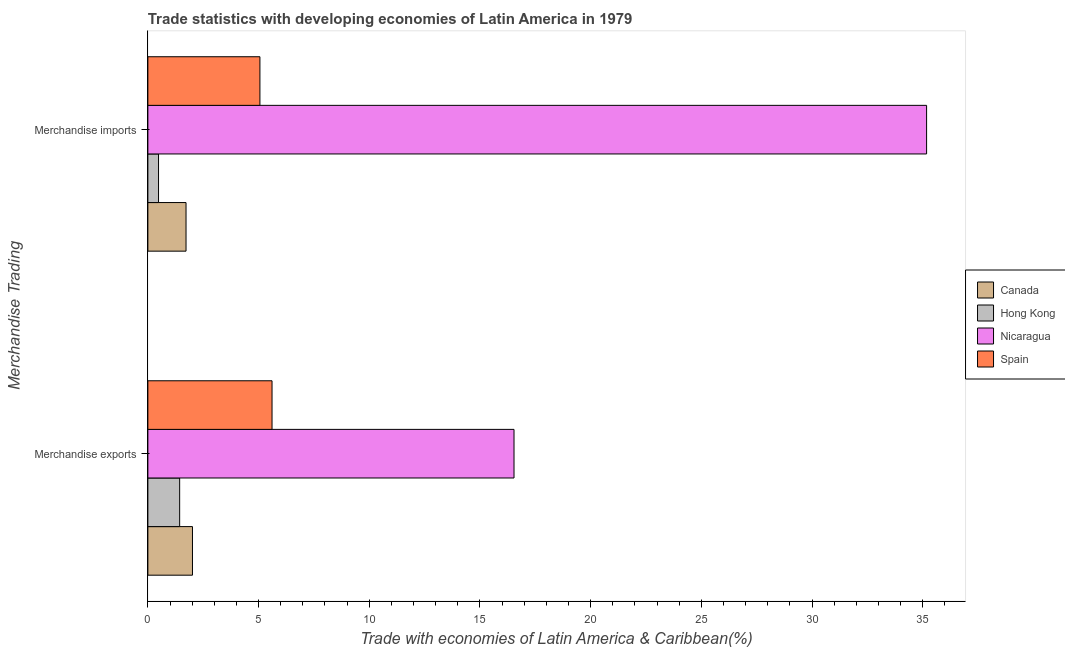How many different coloured bars are there?
Ensure brevity in your answer.  4. How many groups of bars are there?
Offer a very short reply. 2. Are the number of bars on each tick of the Y-axis equal?
Provide a short and direct response. Yes. How many bars are there on the 1st tick from the top?
Provide a succinct answer. 4. What is the merchandise imports in Hong Kong?
Provide a short and direct response. 0.48. Across all countries, what is the maximum merchandise exports?
Your answer should be compact. 16.54. Across all countries, what is the minimum merchandise imports?
Provide a succinct answer. 0.48. In which country was the merchandise imports maximum?
Provide a succinct answer. Nicaragua. In which country was the merchandise imports minimum?
Ensure brevity in your answer.  Hong Kong. What is the total merchandise exports in the graph?
Offer a very short reply. 25.6. What is the difference between the merchandise exports in Spain and that in Hong Kong?
Make the answer very short. 4.17. What is the difference between the merchandise imports in Canada and the merchandise exports in Nicaragua?
Offer a very short reply. -14.82. What is the average merchandise exports per country?
Keep it short and to the point. 6.4. What is the difference between the merchandise exports and merchandise imports in Canada?
Make the answer very short. 0.29. What is the ratio of the merchandise imports in Nicaragua to that in Hong Kong?
Your answer should be very brief. 72.98. What does the 4th bar from the top in Merchandise exports represents?
Offer a terse response. Canada. What does the 1st bar from the bottom in Merchandise exports represents?
Your answer should be compact. Canada. How many bars are there?
Your answer should be very brief. 8. Are all the bars in the graph horizontal?
Keep it short and to the point. Yes. Does the graph contain grids?
Provide a succinct answer. No. How many legend labels are there?
Your response must be concise. 4. What is the title of the graph?
Offer a very short reply. Trade statistics with developing economies of Latin America in 1979. Does "Malawi" appear as one of the legend labels in the graph?
Make the answer very short. No. What is the label or title of the X-axis?
Your answer should be compact. Trade with economies of Latin America & Caribbean(%). What is the label or title of the Y-axis?
Your answer should be compact. Merchandise Trading. What is the Trade with economies of Latin America & Caribbean(%) of Canada in Merchandise exports?
Make the answer very short. 2.01. What is the Trade with economies of Latin America & Caribbean(%) in Hong Kong in Merchandise exports?
Your answer should be compact. 1.44. What is the Trade with economies of Latin America & Caribbean(%) of Nicaragua in Merchandise exports?
Make the answer very short. 16.54. What is the Trade with economies of Latin America & Caribbean(%) of Spain in Merchandise exports?
Keep it short and to the point. 5.61. What is the Trade with economies of Latin America & Caribbean(%) in Canada in Merchandise imports?
Offer a very short reply. 1.72. What is the Trade with economies of Latin America & Caribbean(%) of Hong Kong in Merchandise imports?
Your answer should be very brief. 0.48. What is the Trade with economies of Latin America & Caribbean(%) of Nicaragua in Merchandise imports?
Provide a succinct answer. 35.18. What is the Trade with economies of Latin America & Caribbean(%) of Spain in Merchandise imports?
Keep it short and to the point. 5.06. Across all Merchandise Trading, what is the maximum Trade with economies of Latin America & Caribbean(%) in Canada?
Offer a terse response. 2.01. Across all Merchandise Trading, what is the maximum Trade with economies of Latin America & Caribbean(%) of Hong Kong?
Provide a short and direct response. 1.44. Across all Merchandise Trading, what is the maximum Trade with economies of Latin America & Caribbean(%) of Nicaragua?
Your answer should be very brief. 35.18. Across all Merchandise Trading, what is the maximum Trade with economies of Latin America & Caribbean(%) in Spain?
Your response must be concise. 5.61. Across all Merchandise Trading, what is the minimum Trade with economies of Latin America & Caribbean(%) of Canada?
Offer a terse response. 1.72. Across all Merchandise Trading, what is the minimum Trade with economies of Latin America & Caribbean(%) of Hong Kong?
Your answer should be compact. 0.48. Across all Merchandise Trading, what is the minimum Trade with economies of Latin America & Caribbean(%) in Nicaragua?
Make the answer very short. 16.54. Across all Merchandise Trading, what is the minimum Trade with economies of Latin America & Caribbean(%) in Spain?
Your answer should be very brief. 5.06. What is the total Trade with economies of Latin America & Caribbean(%) of Canada in the graph?
Provide a short and direct response. 3.74. What is the total Trade with economies of Latin America & Caribbean(%) in Hong Kong in the graph?
Ensure brevity in your answer.  1.92. What is the total Trade with economies of Latin America & Caribbean(%) of Nicaragua in the graph?
Provide a short and direct response. 51.72. What is the total Trade with economies of Latin America & Caribbean(%) in Spain in the graph?
Keep it short and to the point. 10.67. What is the difference between the Trade with economies of Latin America & Caribbean(%) in Canada in Merchandise exports and that in Merchandise imports?
Your answer should be compact. 0.29. What is the difference between the Trade with economies of Latin America & Caribbean(%) in Hong Kong in Merchandise exports and that in Merchandise imports?
Your answer should be compact. 0.95. What is the difference between the Trade with economies of Latin America & Caribbean(%) in Nicaragua in Merchandise exports and that in Merchandise imports?
Your answer should be very brief. -18.64. What is the difference between the Trade with economies of Latin America & Caribbean(%) in Spain in Merchandise exports and that in Merchandise imports?
Your answer should be very brief. 0.55. What is the difference between the Trade with economies of Latin America & Caribbean(%) in Canada in Merchandise exports and the Trade with economies of Latin America & Caribbean(%) in Hong Kong in Merchandise imports?
Provide a succinct answer. 1.53. What is the difference between the Trade with economies of Latin America & Caribbean(%) in Canada in Merchandise exports and the Trade with economies of Latin America & Caribbean(%) in Nicaragua in Merchandise imports?
Offer a terse response. -33.16. What is the difference between the Trade with economies of Latin America & Caribbean(%) in Canada in Merchandise exports and the Trade with economies of Latin America & Caribbean(%) in Spain in Merchandise imports?
Keep it short and to the point. -3.05. What is the difference between the Trade with economies of Latin America & Caribbean(%) in Hong Kong in Merchandise exports and the Trade with economies of Latin America & Caribbean(%) in Nicaragua in Merchandise imports?
Ensure brevity in your answer.  -33.74. What is the difference between the Trade with economies of Latin America & Caribbean(%) in Hong Kong in Merchandise exports and the Trade with economies of Latin America & Caribbean(%) in Spain in Merchandise imports?
Give a very brief answer. -3.63. What is the difference between the Trade with economies of Latin America & Caribbean(%) in Nicaragua in Merchandise exports and the Trade with economies of Latin America & Caribbean(%) in Spain in Merchandise imports?
Offer a terse response. 11.48. What is the average Trade with economies of Latin America & Caribbean(%) in Canada per Merchandise Trading?
Give a very brief answer. 1.87. What is the average Trade with economies of Latin America & Caribbean(%) of Hong Kong per Merchandise Trading?
Provide a short and direct response. 0.96. What is the average Trade with economies of Latin America & Caribbean(%) of Nicaragua per Merchandise Trading?
Make the answer very short. 25.86. What is the average Trade with economies of Latin America & Caribbean(%) in Spain per Merchandise Trading?
Your response must be concise. 5.34. What is the difference between the Trade with economies of Latin America & Caribbean(%) of Canada and Trade with economies of Latin America & Caribbean(%) of Hong Kong in Merchandise exports?
Make the answer very short. 0.58. What is the difference between the Trade with economies of Latin America & Caribbean(%) of Canada and Trade with economies of Latin America & Caribbean(%) of Nicaragua in Merchandise exports?
Provide a short and direct response. -14.53. What is the difference between the Trade with economies of Latin America & Caribbean(%) of Canada and Trade with economies of Latin America & Caribbean(%) of Spain in Merchandise exports?
Your answer should be very brief. -3.59. What is the difference between the Trade with economies of Latin America & Caribbean(%) in Hong Kong and Trade with economies of Latin America & Caribbean(%) in Nicaragua in Merchandise exports?
Provide a short and direct response. -15.1. What is the difference between the Trade with economies of Latin America & Caribbean(%) in Hong Kong and Trade with economies of Latin America & Caribbean(%) in Spain in Merchandise exports?
Keep it short and to the point. -4.17. What is the difference between the Trade with economies of Latin America & Caribbean(%) in Nicaragua and Trade with economies of Latin America & Caribbean(%) in Spain in Merchandise exports?
Your answer should be compact. 10.93. What is the difference between the Trade with economies of Latin America & Caribbean(%) in Canada and Trade with economies of Latin America & Caribbean(%) in Hong Kong in Merchandise imports?
Offer a terse response. 1.24. What is the difference between the Trade with economies of Latin America & Caribbean(%) in Canada and Trade with economies of Latin America & Caribbean(%) in Nicaragua in Merchandise imports?
Your answer should be very brief. -33.45. What is the difference between the Trade with economies of Latin America & Caribbean(%) of Canada and Trade with economies of Latin America & Caribbean(%) of Spain in Merchandise imports?
Keep it short and to the point. -3.34. What is the difference between the Trade with economies of Latin America & Caribbean(%) of Hong Kong and Trade with economies of Latin America & Caribbean(%) of Nicaragua in Merchandise imports?
Give a very brief answer. -34.69. What is the difference between the Trade with economies of Latin America & Caribbean(%) in Hong Kong and Trade with economies of Latin America & Caribbean(%) in Spain in Merchandise imports?
Offer a very short reply. -4.58. What is the difference between the Trade with economies of Latin America & Caribbean(%) in Nicaragua and Trade with economies of Latin America & Caribbean(%) in Spain in Merchandise imports?
Your answer should be compact. 30.11. What is the ratio of the Trade with economies of Latin America & Caribbean(%) in Canada in Merchandise exports to that in Merchandise imports?
Ensure brevity in your answer.  1.17. What is the ratio of the Trade with economies of Latin America & Caribbean(%) of Hong Kong in Merchandise exports to that in Merchandise imports?
Your answer should be compact. 2.98. What is the ratio of the Trade with economies of Latin America & Caribbean(%) of Nicaragua in Merchandise exports to that in Merchandise imports?
Make the answer very short. 0.47. What is the ratio of the Trade with economies of Latin America & Caribbean(%) in Spain in Merchandise exports to that in Merchandise imports?
Your answer should be very brief. 1.11. What is the difference between the highest and the second highest Trade with economies of Latin America & Caribbean(%) in Canada?
Give a very brief answer. 0.29. What is the difference between the highest and the second highest Trade with economies of Latin America & Caribbean(%) of Hong Kong?
Your response must be concise. 0.95. What is the difference between the highest and the second highest Trade with economies of Latin America & Caribbean(%) in Nicaragua?
Your answer should be compact. 18.64. What is the difference between the highest and the second highest Trade with economies of Latin America & Caribbean(%) of Spain?
Provide a succinct answer. 0.55. What is the difference between the highest and the lowest Trade with economies of Latin America & Caribbean(%) of Canada?
Provide a succinct answer. 0.29. What is the difference between the highest and the lowest Trade with economies of Latin America & Caribbean(%) of Hong Kong?
Give a very brief answer. 0.95. What is the difference between the highest and the lowest Trade with economies of Latin America & Caribbean(%) of Nicaragua?
Provide a short and direct response. 18.64. What is the difference between the highest and the lowest Trade with economies of Latin America & Caribbean(%) in Spain?
Keep it short and to the point. 0.55. 